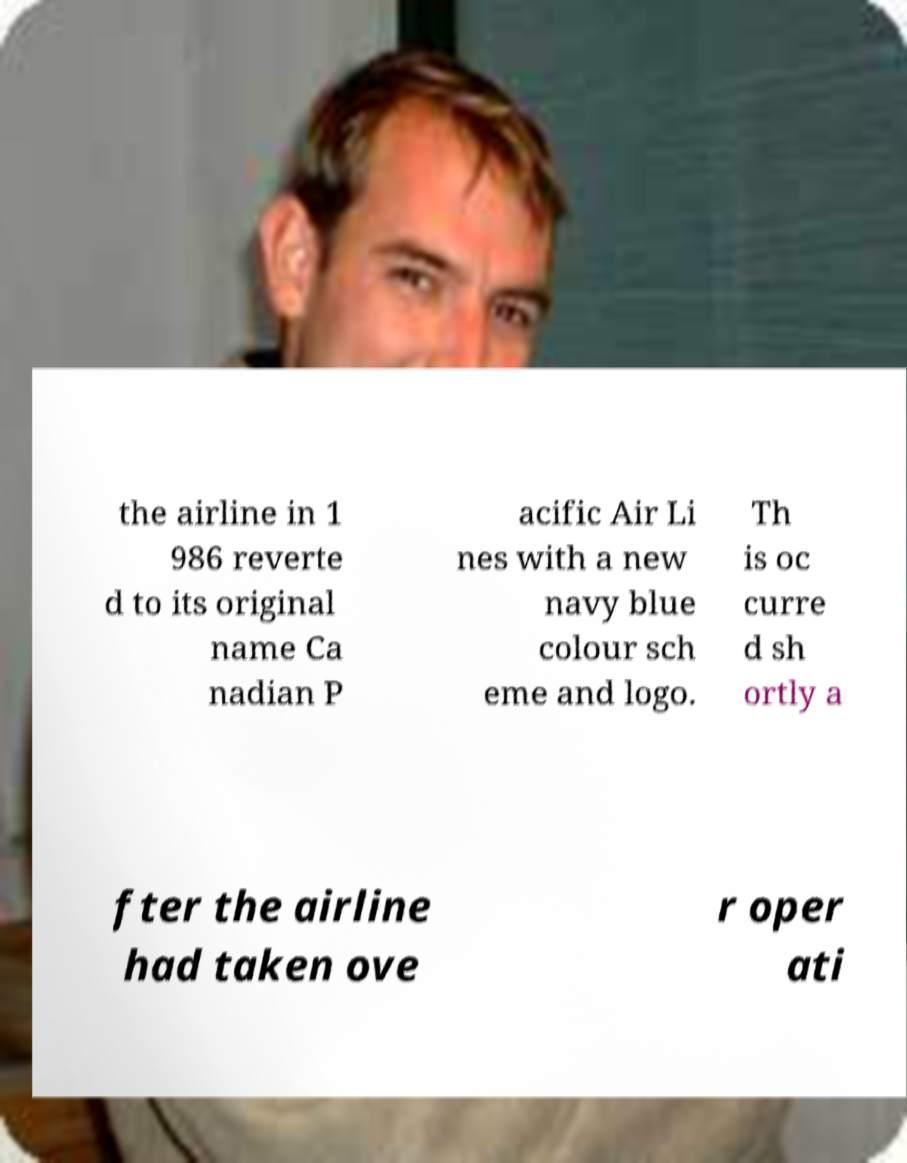Could you extract and type out the text from this image? the airline in 1 986 reverte d to its original name Ca nadian P acific Air Li nes with a new navy blue colour sch eme and logo. Th is oc curre d sh ortly a fter the airline had taken ove r oper ati 